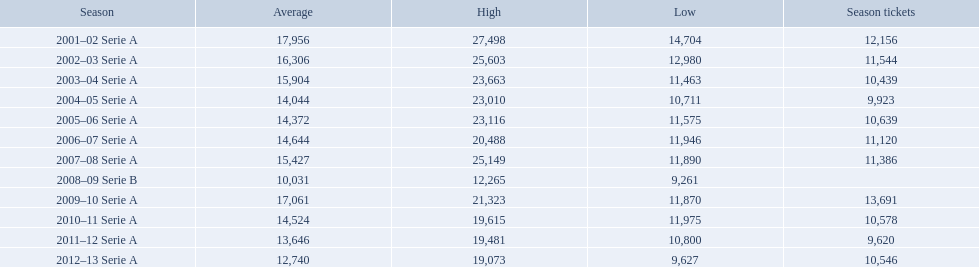What seasons were played at the stadio ennio tardini 2001–02 Serie A, 2002–03 Serie A, 2003–04 Serie A, 2004–05 Serie A, 2005–06 Serie A, 2006–07 Serie A, 2007–08 Serie A, 2008–09 Serie B, 2009–10 Serie A, 2010–11 Serie A, 2011–12 Serie A, 2012–13 Serie A. Which of these seasons had season tickets? 2001–02 Serie A, 2002–03 Serie A, 2003–04 Serie A, 2004–05 Serie A, 2005–06 Serie A, 2006–07 Serie A, 2007–08 Serie A, 2009–10 Serie A, 2010–11 Serie A, 2011–12 Serie A, 2012–13 Serie A. How many season tickets did the 2007-08 season have? 11,386. When did all the seasons occur? 2001–02 Serie A, 2002–03 Serie A, 2003–04 Serie A, 2004–05 Serie A, 2005–06 Serie A, 2006–07 Serie A, 2007–08 Serie A, 2008–09 Serie B, 2009–10 Serie A, 2010–11 Serie A, 2011–12 Serie A, 2012–13 Serie A. How many passes were purchased? 12,156, 11,544, 10,439, 9,923, 10,639, 11,120, 11,386, , 13,691, 10,578, 9,620, 10,546. What about specifically in the 2007 season? 11,386. When did the seasons take place? 2001–02 Serie A, 2002–03 Serie A, 2003–04 Serie A, 2004–05 Serie A, 2005–06 Serie A, 2006–07 Serie A, 2007–08 Serie A, 2008–09 Serie B, 2009–10 Serie A, 2010–11 Serie A, 2011–12 Serie A, 2012–13 Serie A. How many admissions were sold? 12,156, 11,544, 10,439, 9,923, 10,639, 11,120, 11,386, , 13,691, 10,578, 9,620, 10,546. What about exclusively in the 2007 season? 11,386. What are the different seasons? 2001–02 Serie A, 2002–03 Serie A, 2003–04 Serie A, 2004–05 Serie A, 2005–06 Serie A, 2006–07 Serie A, 2007–08 Serie A, 2008–09 Serie B, 2009–10 Serie A, 2010–11 Serie A, 2011–12 Serie A, 2012–13 Serie A. Which specific season occurred in 2007? 2007–08 Serie A. How many seasonal passes were purchased during that period? 11,386. In which years did the seasons occur? 2001–02 Serie A, 2002–03 Serie A, 2003–04 Serie A, 2004–05 Serie A, 2005–06 Serie A, 2006–07 Serie A, 2007–08 Serie A, 2008–09 Serie B, 2009–10 Serie A, 2010–11 Serie A, 2011–12 Serie A, 2012–13 Serie A. What is the overall count of tickets sold? 12,156, 11,544, 10,439, 9,923, 10,639, 11,120, 11,386, , 13,691, 10,578, 9,620, 10,546. Can you provide the sales figures for the 2007 season alone? 11,386. During which time periods were the seasons held? 2001–02 Serie A, 2002–03 Serie A, 2003–04 Serie A, 2004–05 Serie A, 2005–06 Serie A, 2006–07 Serie A, 2007–08 Serie A, 2008–09 Serie B, 2009–10 Serie A, 2010–11 Serie A, 2011–12 Serie A, 2012–13 Serie A. How many tickets were purchased in total? 12,156, 11,544, 10,439, 9,923, 10,639, 11,120, 11,386, , 13,691, 10,578, 9,620, 10,546. What was the ticket sale count for just the 2007 season? 11,386. Can you list the seasons? 2001–02 Serie A, 2002–03 Serie A, 2003–04 Serie A, 2004–05 Serie A, 2005–06 Serie A, 2006–07 Serie A, 2007–08 Serie A, 2008–09 Serie B, 2009–10 Serie A, 2010–11 Serie A, 2011–12 Serie A, 2012–13 Serie A. Which one took place in 2007? 2007–08 Serie A. What was the number of season tickets sold during that specific season? 11,386. What are the different seasons? 2001–02 Serie A, 2002–03 Serie A, 2003–04 Serie A, 2004–05 Serie A, 2005–06 Serie A, 2006–07 Serie A, 2007–08 Serie A, 2008–09 Serie B, 2009–10 Serie A, 2010–11 Serie A, 2011–12 Serie A, 2012–13 Serie A. In 2007, which season was it? 2007–08 Serie A. How many season tickets were bought for that particular season? 11,386. 